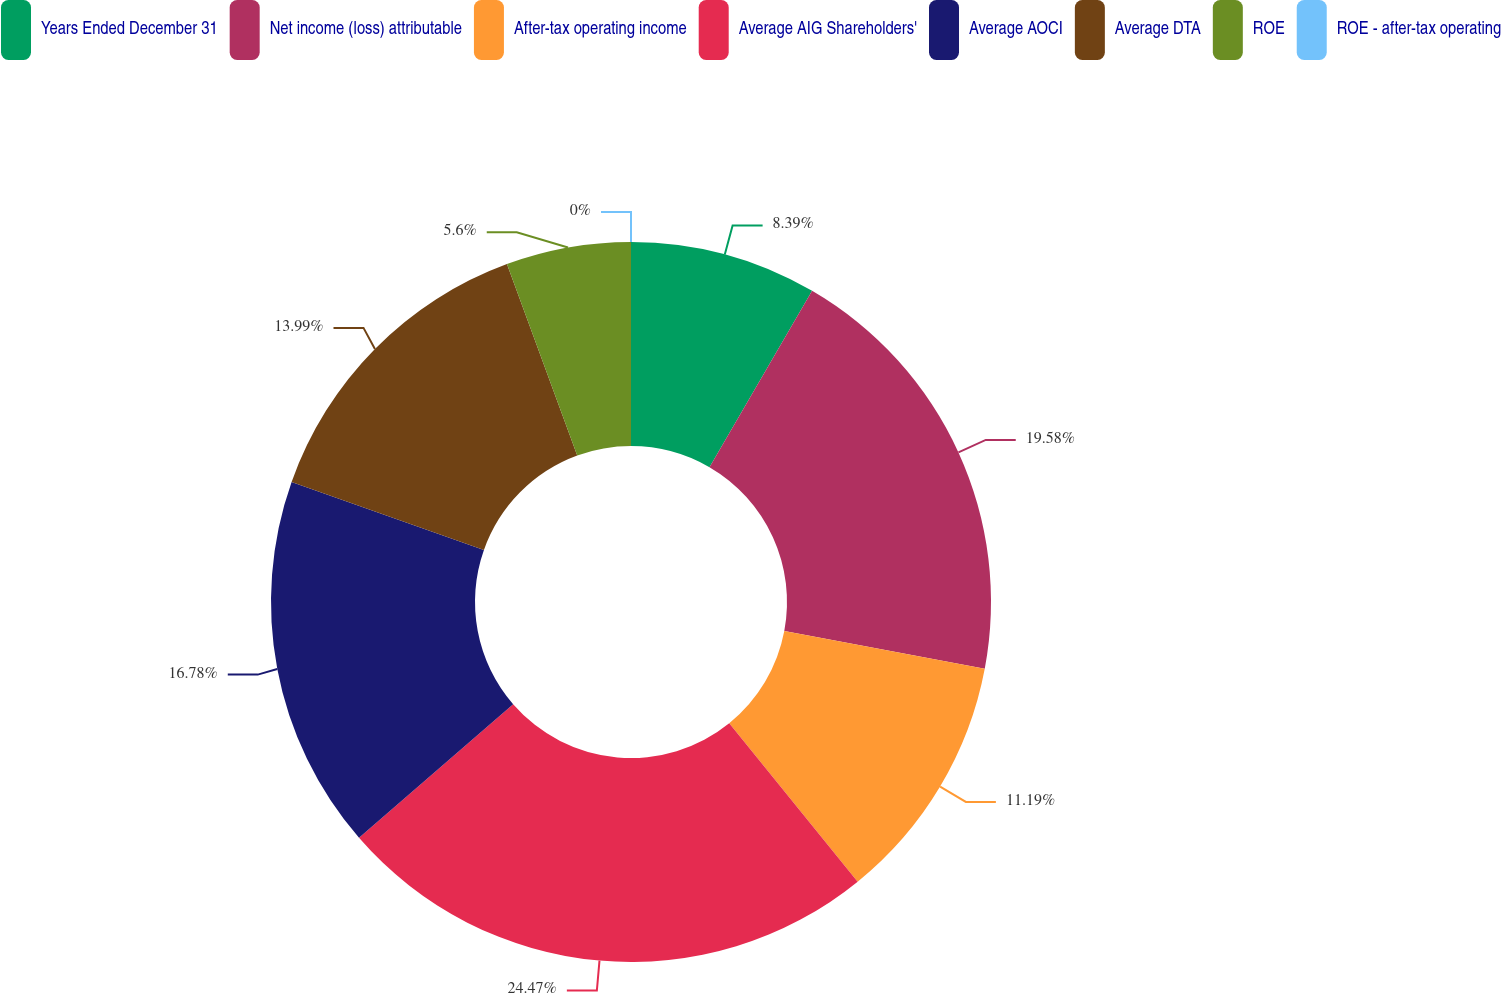<chart> <loc_0><loc_0><loc_500><loc_500><pie_chart><fcel>Years Ended December 31<fcel>Net income (loss) attributable<fcel>After-tax operating income<fcel>Average AIG Shareholders'<fcel>Average AOCI<fcel>Average DTA<fcel>ROE<fcel>ROE - after-tax operating<nl><fcel>8.39%<fcel>19.58%<fcel>11.19%<fcel>24.47%<fcel>16.78%<fcel>13.99%<fcel>5.6%<fcel>0.0%<nl></chart> 